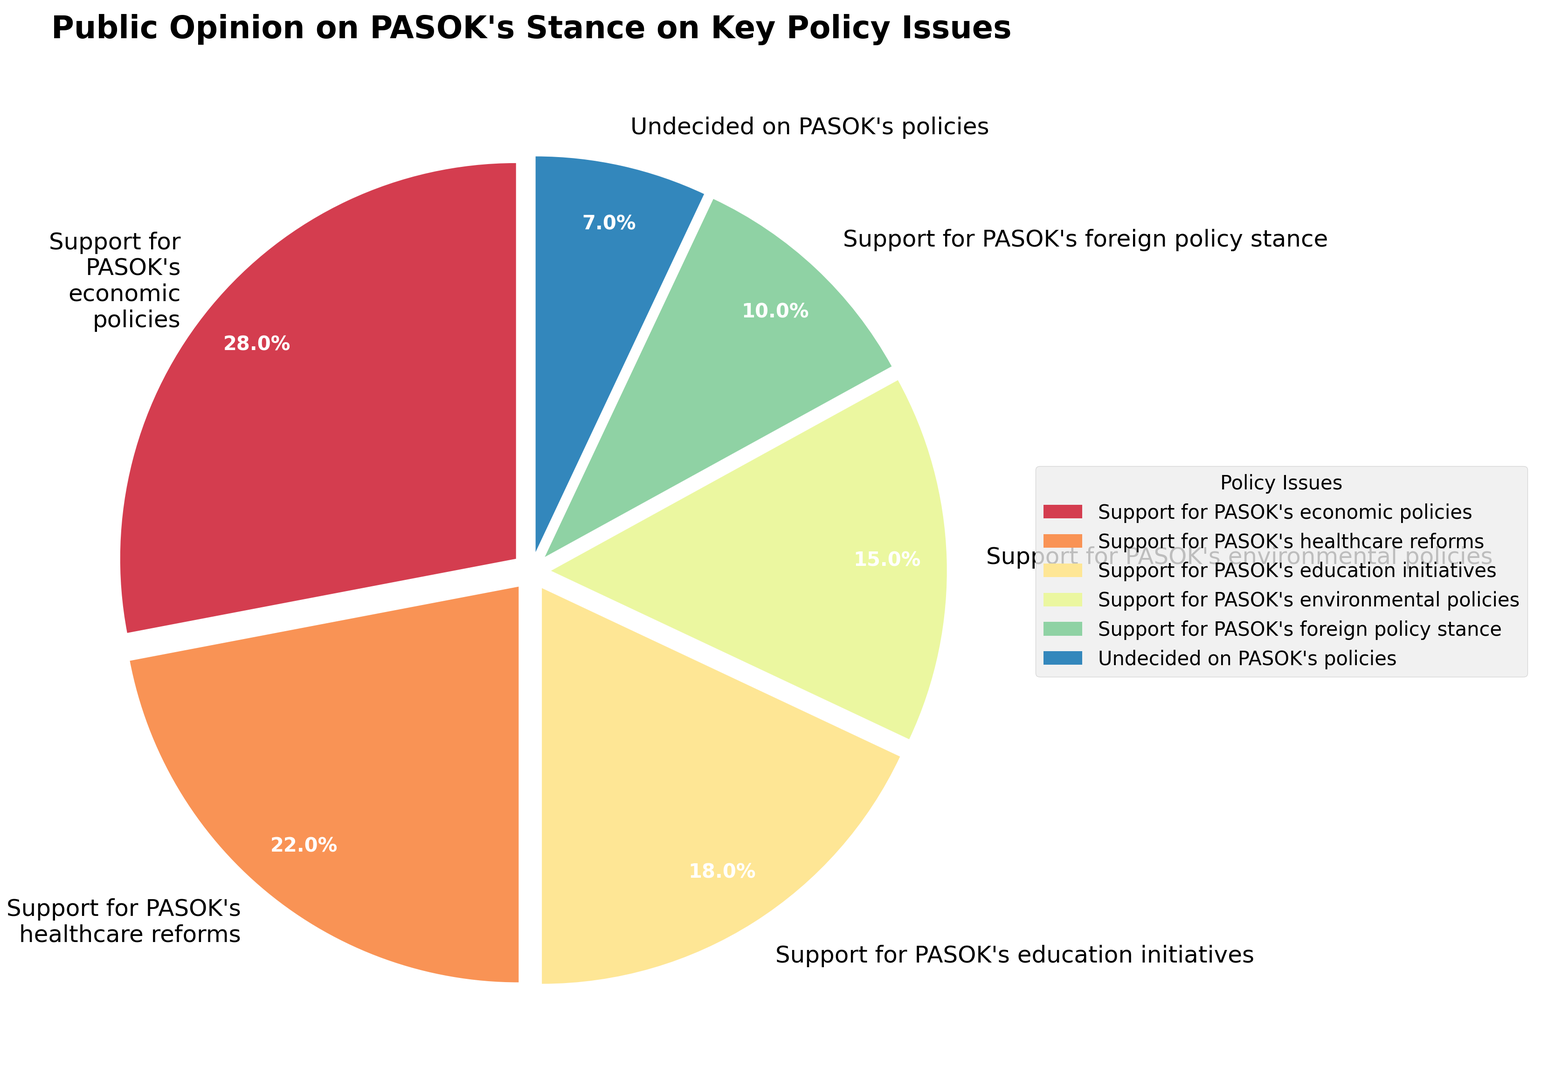Which policy issue has the highest level of support? To find out which policy issue has the highest level of support, examine each segment's percentage value in the pie chart. The 'Support for PASOK's economic policies' segment has the highest percentage at 28%.
Answer: Support for PASOK's economic policies What is the total percentage of people supporting PASOK's healthcare reforms and education initiatives? To calculate the total percentage, you add the percentage of 'PASOK's healthcare reforms' (22%) to 'PASOK's education initiatives' (18%) which equals 40%.
Answer: 40% How does support for PASOK's economic policies compare to support for their environmental policies? To compare, note the percentage values for both policies. 'Support for PASOK's economic policies' is at 28%, while 'Support for PASOK's environmental policies' is at 15%. The economic policies have a higher level of support.
Answer: Higher What percentage of people are undecided on PASOK's policies? This can be directly read from the pie chart segment labeled 'Undecided on PASOK's policies', which is 7%.
Answer: 7% How much greater is the support for PASOK's foreign policy stance compared to the undecided group? Subtract the percentage of 'Undecided on PASOK's policies' (7%) from 'Support for PASOK's foreign policy stance' (10%), resulting in a difference of 3%.
Answer: 3% Which two policy issues combined have a majority (more than 50%) of support? Adding the support for the top two individual policies gives the combined percentage. 'Support for PASOK's economic policies' (28%) and 'Support for PASOK's healthcare reforms' (22%) together make 50%, while adding any smaller issues stays under 50%.
Answer: None What color represents support for PASOK's education initiatives? Look for the segment labeled 'Support for PASOK's education initiatives' in the pie chart and identify its color. Without seeing the chart, assume it matches one of the Spectral colors.
Answer: (Use the color visible in the chart, e.g., "yellow" if it appears so) Is there any policy issue that has less than 10% support? By inspecting the pie chart segments and their respective percentages, 'Support for PASOK's foreign policy stance' is exactly 10%, so none of the policies have less than 10%.
Answer: No What's the difference in percentage between the support for PASOK's healthcare reforms and education initiatives? Subtract the percentage for 'Support for PASOK's education initiatives' (18%) from 'Support for PASOK's healthcare reforms' (22%), which equals 4%.
Answer: 4% 